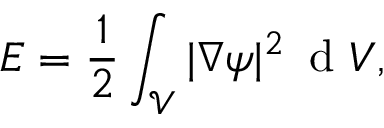<formula> <loc_0><loc_0><loc_500><loc_500>E = \frac { 1 } { 2 } \int _ { \mathcal { V } } | \nabla \psi | ^ { 2 } \, d V ,</formula> 